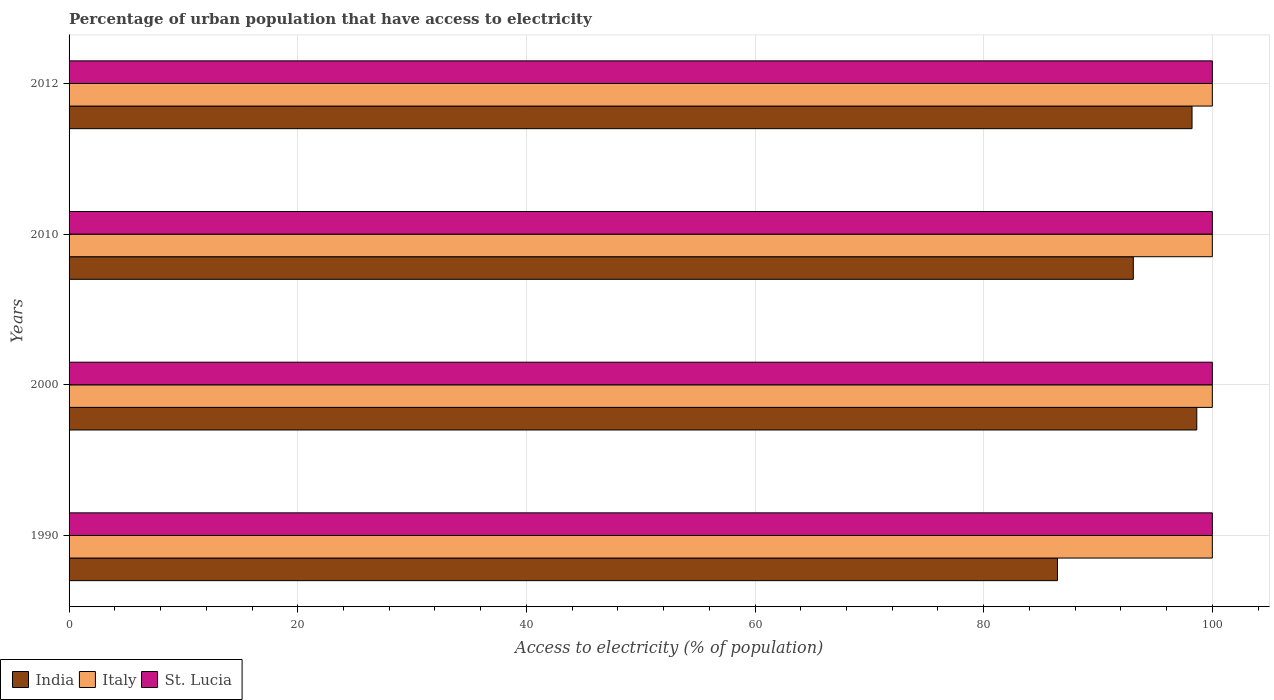How many different coloured bars are there?
Offer a terse response. 3. How many bars are there on the 3rd tick from the top?
Offer a very short reply. 3. What is the label of the 2nd group of bars from the top?
Make the answer very short. 2010. What is the percentage of urban population that have access to electricity in St. Lucia in 2012?
Provide a short and direct response. 100. Across all years, what is the maximum percentage of urban population that have access to electricity in St. Lucia?
Keep it short and to the point. 100. Across all years, what is the minimum percentage of urban population that have access to electricity in India?
Give a very brief answer. 86.46. In which year was the percentage of urban population that have access to electricity in India maximum?
Your answer should be compact. 2000. In which year was the percentage of urban population that have access to electricity in Italy minimum?
Your answer should be very brief. 1990. What is the total percentage of urban population that have access to electricity in India in the graph?
Make the answer very short. 376.41. What is the difference between the percentage of urban population that have access to electricity in Italy in 1990 and the percentage of urban population that have access to electricity in St. Lucia in 2010?
Keep it short and to the point. 0. What is the average percentage of urban population that have access to electricity in India per year?
Your answer should be very brief. 94.1. In the year 2000, what is the difference between the percentage of urban population that have access to electricity in St. Lucia and percentage of urban population that have access to electricity in India?
Provide a succinct answer. 1.36. In how many years, is the percentage of urban population that have access to electricity in Italy greater than 56 %?
Make the answer very short. 4. What is the ratio of the percentage of urban population that have access to electricity in India in 2000 to that in 2012?
Give a very brief answer. 1. Is the percentage of urban population that have access to electricity in St. Lucia in 2010 less than that in 2012?
Give a very brief answer. No. Is the difference between the percentage of urban population that have access to electricity in St. Lucia in 1990 and 2012 greater than the difference between the percentage of urban population that have access to electricity in India in 1990 and 2012?
Make the answer very short. Yes. What does the 3rd bar from the top in 1990 represents?
Provide a short and direct response. India. What does the 3rd bar from the bottom in 1990 represents?
Keep it short and to the point. St. Lucia. How many bars are there?
Give a very brief answer. 12. Does the graph contain grids?
Your answer should be very brief. Yes. Where does the legend appear in the graph?
Provide a succinct answer. Bottom left. How many legend labels are there?
Your answer should be very brief. 3. What is the title of the graph?
Your answer should be compact. Percentage of urban population that have access to electricity. Does "Small states" appear as one of the legend labels in the graph?
Offer a terse response. No. What is the label or title of the X-axis?
Offer a terse response. Access to electricity (% of population). What is the Access to electricity (% of population) of India in 1990?
Provide a succinct answer. 86.46. What is the Access to electricity (% of population) in Italy in 1990?
Provide a short and direct response. 100. What is the Access to electricity (% of population) in St. Lucia in 1990?
Make the answer very short. 100. What is the Access to electricity (% of population) of India in 2000?
Ensure brevity in your answer.  98.64. What is the Access to electricity (% of population) in Italy in 2000?
Provide a short and direct response. 100. What is the Access to electricity (% of population) in India in 2010?
Your answer should be very brief. 93.09. What is the Access to electricity (% of population) in Italy in 2010?
Your answer should be very brief. 100. What is the Access to electricity (% of population) in St. Lucia in 2010?
Ensure brevity in your answer.  100. What is the Access to electricity (% of population) in India in 2012?
Your answer should be compact. 98.23. What is the Access to electricity (% of population) in St. Lucia in 2012?
Keep it short and to the point. 100. Across all years, what is the maximum Access to electricity (% of population) of India?
Your answer should be compact. 98.64. Across all years, what is the maximum Access to electricity (% of population) in Italy?
Your answer should be very brief. 100. Across all years, what is the maximum Access to electricity (% of population) in St. Lucia?
Your answer should be very brief. 100. Across all years, what is the minimum Access to electricity (% of population) of India?
Your answer should be very brief. 86.46. Across all years, what is the minimum Access to electricity (% of population) in Italy?
Ensure brevity in your answer.  100. Across all years, what is the minimum Access to electricity (% of population) in St. Lucia?
Your response must be concise. 100. What is the total Access to electricity (% of population) of India in the graph?
Ensure brevity in your answer.  376.41. What is the total Access to electricity (% of population) in Italy in the graph?
Provide a short and direct response. 400. What is the total Access to electricity (% of population) in St. Lucia in the graph?
Your response must be concise. 400. What is the difference between the Access to electricity (% of population) in India in 1990 and that in 2000?
Offer a terse response. -12.19. What is the difference between the Access to electricity (% of population) of India in 1990 and that in 2010?
Offer a terse response. -6.63. What is the difference between the Access to electricity (% of population) of Italy in 1990 and that in 2010?
Provide a succinct answer. 0. What is the difference between the Access to electricity (% of population) in India in 1990 and that in 2012?
Provide a short and direct response. -11.77. What is the difference between the Access to electricity (% of population) in St. Lucia in 1990 and that in 2012?
Your answer should be compact. 0. What is the difference between the Access to electricity (% of population) of India in 2000 and that in 2010?
Give a very brief answer. 5.55. What is the difference between the Access to electricity (% of population) in India in 2000 and that in 2012?
Your answer should be compact. 0.42. What is the difference between the Access to electricity (% of population) of Italy in 2000 and that in 2012?
Provide a short and direct response. 0. What is the difference between the Access to electricity (% of population) of India in 2010 and that in 2012?
Offer a very short reply. -5.14. What is the difference between the Access to electricity (% of population) in Italy in 2010 and that in 2012?
Keep it short and to the point. 0. What is the difference between the Access to electricity (% of population) of India in 1990 and the Access to electricity (% of population) of Italy in 2000?
Offer a very short reply. -13.54. What is the difference between the Access to electricity (% of population) of India in 1990 and the Access to electricity (% of population) of St. Lucia in 2000?
Your answer should be compact. -13.54. What is the difference between the Access to electricity (% of population) in Italy in 1990 and the Access to electricity (% of population) in St. Lucia in 2000?
Give a very brief answer. 0. What is the difference between the Access to electricity (% of population) in India in 1990 and the Access to electricity (% of population) in Italy in 2010?
Your answer should be compact. -13.54. What is the difference between the Access to electricity (% of population) of India in 1990 and the Access to electricity (% of population) of St. Lucia in 2010?
Your answer should be compact. -13.54. What is the difference between the Access to electricity (% of population) of India in 1990 and the Access to electricity (% of population) of Italy in 2012?
Keep it short and to the point. -13.54. What is the difference between the Access to electricity (% of population) of India in 1990 and the Access to electricity (% of population) of St. Lucia in 2012?
Provide a succinct answer. -13.54. What is the difference between the Access to electricity (% of population) in India in 2000 and the Access to electricity (% of population) in Italy in 2010?
Make the answer very short. -1.36. What is the difference between the Access to electricity (% of population) in India in 2000 and the Access to electricity (% of population) in St. Lucia in 2010?
Provide a short and direct response. -1.36. What is the difference between the Access to electricity (% of population) of Italy in 2000 and the Access to electricity (% of population) of St. Lucia in 2010?
Keep it short and to the point. 0. What is the difference between the Access to electricity (% of population) of India in 2000 and the Access to electricity (% of population) of Italy in 2012?
Provide a short and direct response. -1.36. What is the difference between the Access to electricity (% of population) of India in 2000 and the Access to electricity (% of population) of St. Lucia in 2012?
Your response must be concise. -1.36. What is the difference between the Access to electricity (% of population) in India in 2010 and the Access to electricity (% of population) in Italy in 2012?
Your answer should be compact. -6.91. What is the difference between the Access to electricity (% of population) in India in 2010 and the Access to electricity (% of population) in St. Lucia in 2012?
Make the answer very short. -6.91. What is the average Access to electricity (% of population) in India per year?
Your response must be concise. 94.1. What is the average Access to electricity (% of population) in Italy per year?
Offer a terse response. 100. What is the average Access to electricity (% of population) of St. Lucia per year?
Offer a very short reply. 100. In the year 1990, what is the difference between the Access to electricity (% of population) of India and Access to electricity (% of population) of Italy?
Provide a succinct answer. -13.54. In the year 1990, what is the difference between the Access to electricity (% of population) of India and Access to electricity (% of population) of St. Lucia?
Your response must be concise. -13.54. In the year 2000, what is the difference between the Access to electricity (% of population) in India and Access to electricity (% of population) in Italy?
Ensure brevity in your answer.  -1.36. In the year 2000, what is the difference between the Access to electricity (% of population) of India and Access to electricity (% of population) of St. Lucia?
Make the answer very short. -1.36. In the year 2000, what is the difference between the Access to electricity (% of population) of Italy and Access to electricity (% of population) of St. Lucia?
Provide a short and direct response. 0. In the year 2010, what is the difference between the Access to electricity (% of population) of India and Access to electricity (% of population) of Italy?
Your answer should be very brief. -6.91. In the year 2010, what is the difference between the Access to electricity (% of population) in India and Access to electricity (% of population) in St. Lucia?
Give a very brief answer. -6.91. In the year 2010, what is the difference between the Access to electricity (% of population) of Italy and Access to electricity (% of population) of St. Lucia?
Give a very brief answer. 0. In the year 2012, what is the difference between the Access to electricity (% of population) of India and Access to electricity (% of population) of Italy?
Your response must be concise. -1.77. In the year 2012, what is the difference between the Access to electricity (% of population) of India and Access to electricity (% of population) of St. Lucia?
Keep it short and to the point. -1.77. In the year 2012, what is the difference between the Access to electricity (% of population) of Italy and Access to electricity (% of population) of St. Lucia?
Provide a succinct answer. 0. What is the ratio of the Access to electricity (% of population) in India in 1990 to that in 2000?
Your answer should be compact. 0.88. What is the ratio of the Access to electricity (% of population) in India in 1990 to that in 2010?
Your response must be concise. 0.93. What is the ratio of the Access to electricity (% of population) of India in 1990 to that in 2012?
Make the answer very short. 0.88. What is the ratio of the Access to electricity (% of population) in India in 2000 to that in 2010?
Provide a short and direct response. 1.06. What is the ratio of the Access to electricity (% of population) of India in 2000 to that in 2012?
Provide a succinct answer. 1. What is the ratio of the Access to electricity (% of population) in St. Lucia in 2000 to that in 2012?
Offer a very short reply. 1. What is the ratio of the Access to electricity (% of population) of India in 2010 to that in 2012?
Provide a short and direct response. 0.95. What is the difference between the highest and the second highest Access to electricity (% of population) of India?
Make the answer very short. 0.42. What is the difference between the highest and the second highest Access to electricity (% of population) in Italy?
Ensure brevity in your answer.  0. What is the difference between the highest and the lowest Access to electricity (% of population) of India?
Keep it short and to the point. 12.19. What is the difference between the highest and the lowest Access to electricity (% of population) in Italy?
Your answer should be compact. 0. 